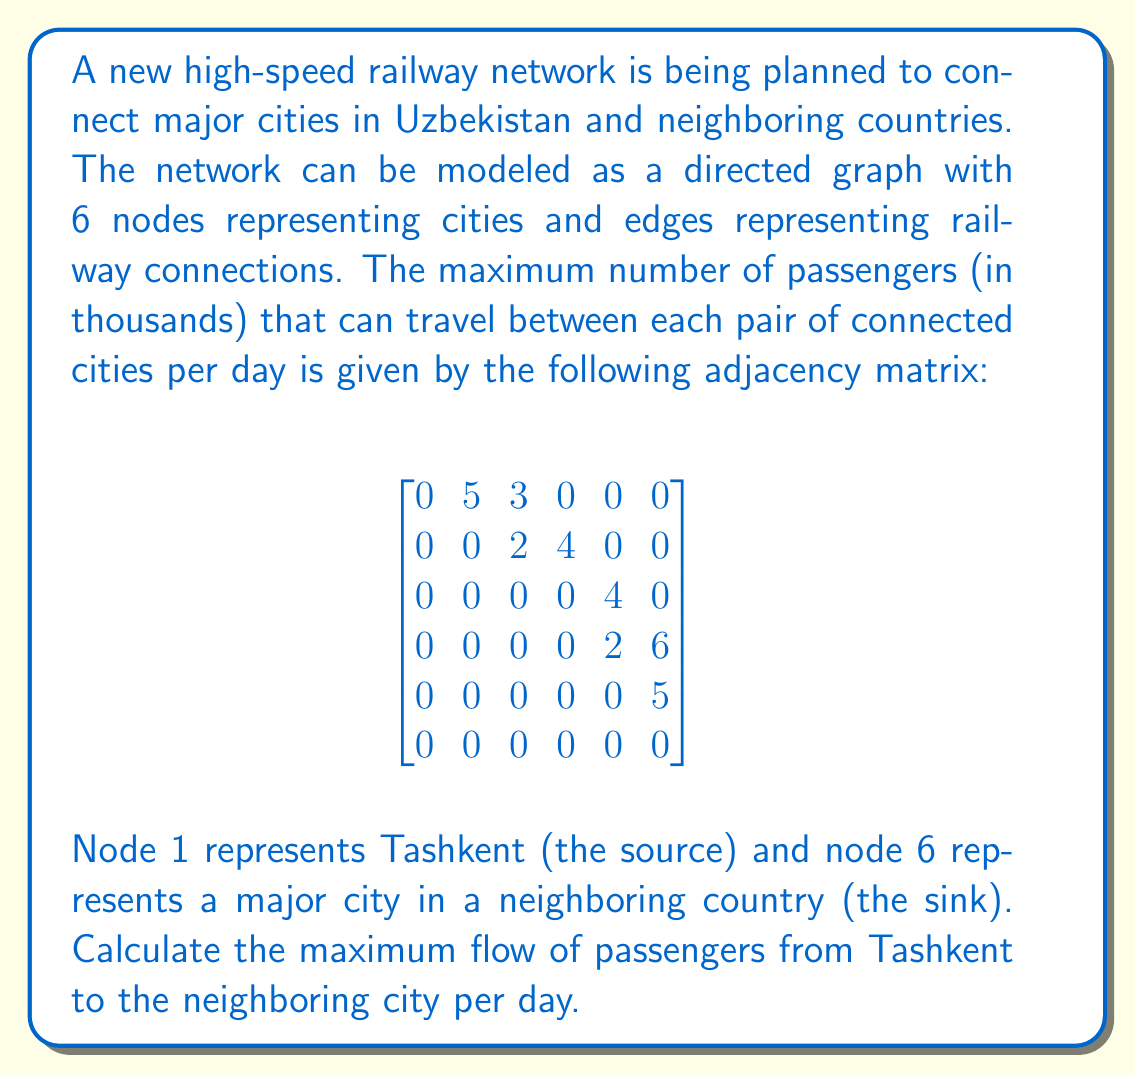Could you help me with this problem? To solve this problem, we'll use the Ford-Fulkerson algorithm to find the maximum flow in the network.

Step 1: Identify augmenting paths from source to sink.

Path 1: 1 → 2 → 4 → 6
Flow: min(5, 4, 6) = 4

Path 2: 1 → 3 → 5 → 6
Flow: min(3, 4, 5) = 3

Path 3: 1 → 2 → 3 → 5 → 6
Flow: min(5, 2, 4, 5) = 2

Step 2: Calculate the total flow.

Total flow = 4 + 3 + 2 = 9

Step 3: Verify that no more augmenting paths exist.

After applying the flows from the three paths, the residual graph becomes:

$$
\begin{bmatrix}
0 & 0 & 0 & 0 & 0 & 0 \\
0 & 0 & 0 & 0 & 0 & 0 \\
0 & 0 & 0 & 0 & 0 & 0 \\
0 & 0 & 0 & 0 & 0 & 0 \\
0 & 0 & 0 & 0 & 0 & 0 \\
0 & 0 & 0 & 0 & 0 & 0
\end{bmatrix}
$$

There are no more augmenting paths from source to sink, confirming that we have found the maximum flow.
Answer: The maximum flow of passengers from Tashkent to the neighboring city is 9,000 passengers per day. 